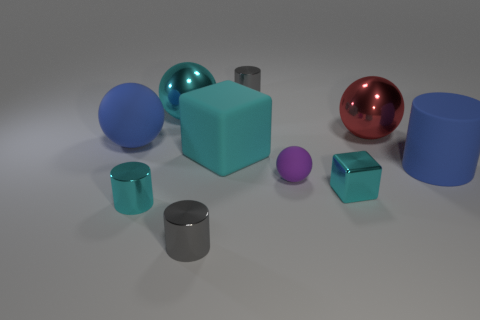Subtract all tiny purple spheres. How many spheres are left? 3 Subtract 3 balls. How many balls are left? 1 Subtract all cyan cylinders. How many cylinders are left? 3 Subtract all balls. How many objects are left? 6 Subtract all small gray shiny objects. Subtract all big cylinders. How many objects are left? 7 Add 1 shiny cylinders. How many shiny cylinders are left? 4 Add 9 big red rubber spheres. How many big red rubber spheres exist? 9 Subtract 1 cyan spheres. How many objects are left? 9 Subtract all brown cylinders. Subtract all red blocks. How many cylinders are left? 4 Subtract all green cubes. How many cyan spheres are left? 1 